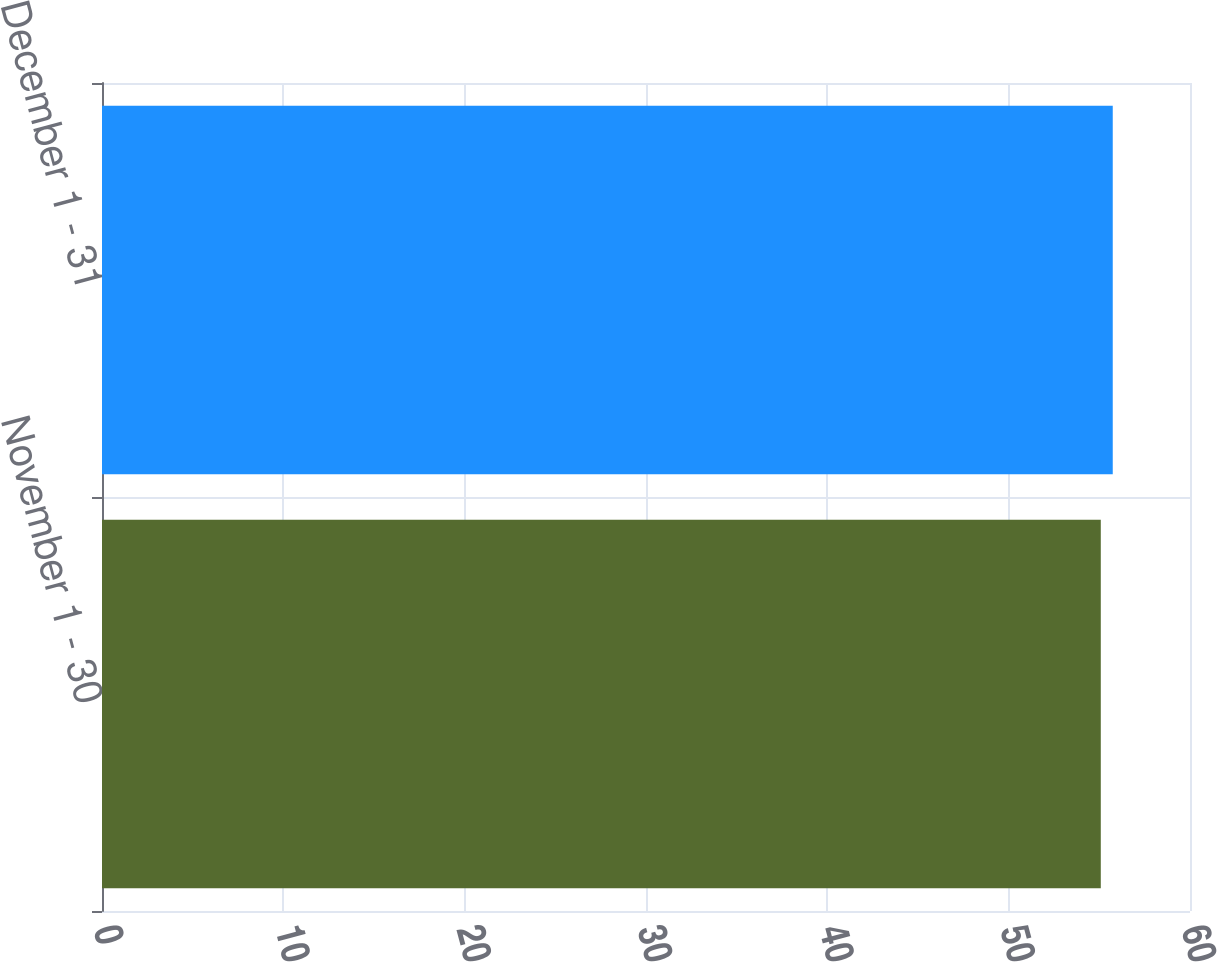<chart> <loc_0><loc_0><loc_500><loc_500><bar_chart><fcel>November 1 - 30<fcel>December 1 - 31<nl><fcel>55.08<fcel>55.74<nl></chart> 